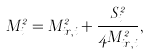Convert formula to latex. <formula><loc_0><loc_0><loc_500><loc_500>M _ { i } ^ { 2 } = M _ { i r , i } ^ { 2 } + \frac { S _ { i } ^ { 2 } } { 4 M _ { i r , i } ^ { 2 } } ,</formula> 